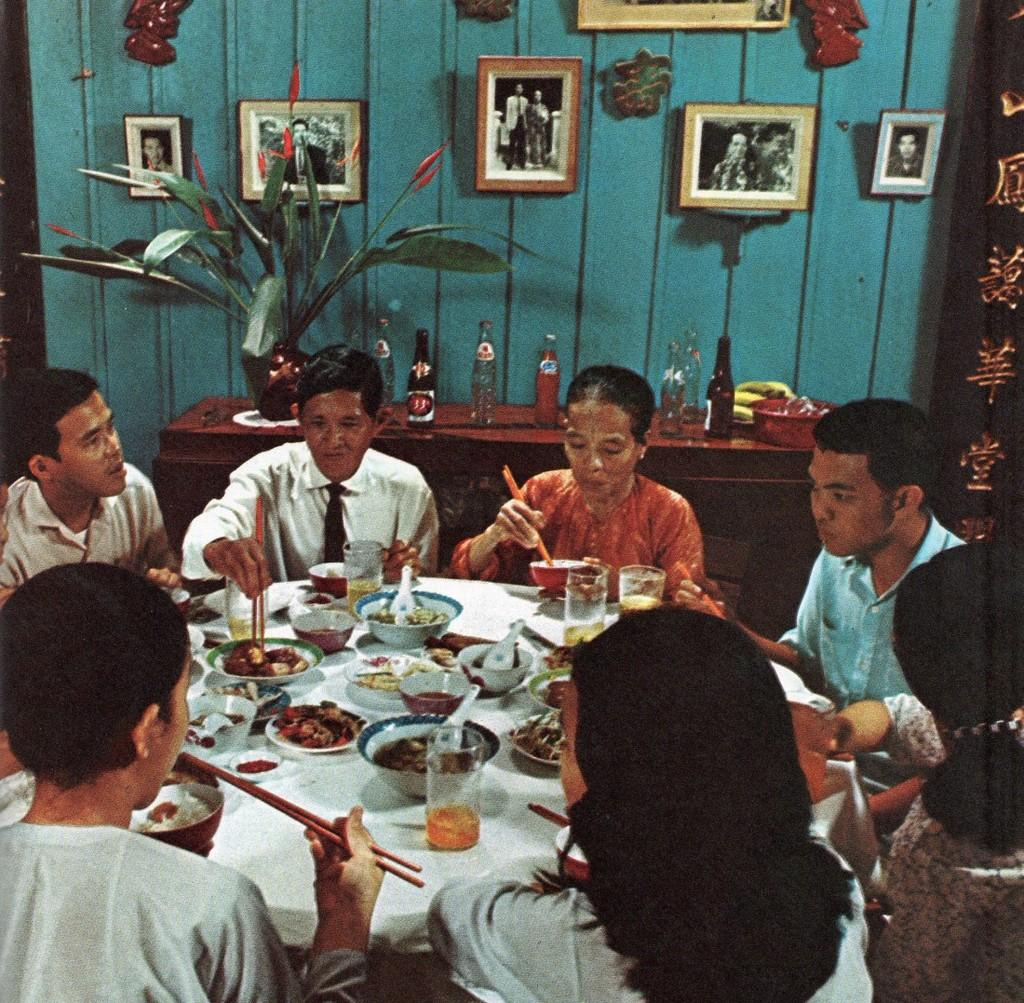What is happening in the image involving the group of people? The people are having dinner together in the image. What can be seen on the table where the people are dining? There are dishes on the dining table. What is visible in the background of the image? There is a wall visible in the background. What decorative items are present on the wall? There are photo frames on the wall. How much income does the dust on the table contribute to the household in the image? There is no dust visible on the table in the image, and therefore it cannot contribute any income to the household. 